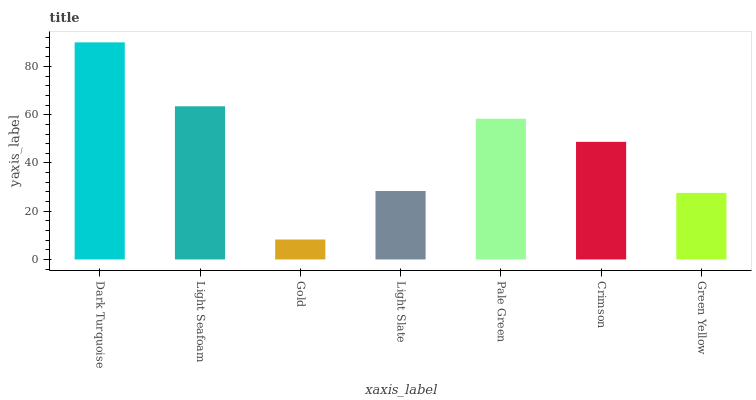Is Light Seafoam the minimum?
Answer yes or no. No. Is Light Seafoam the maximum?
Answer yes or no. No. Is Dark Turquoise greater than Light Seafoam?
Answer yes or no. Yes. Is Light Seafoam less than Dark Turquoise?
Answer yes or no. Yes. Is Light Seafoam greater than Dark Turquoise?
Answer yes or no. No. Is Dark Turquoise less than Light Seafoam?
Answer yes or no. No. Is Crimson the high median?
Answer yes or no. Yes. Is Crimson the low median?
Answer yes or no. Yes. Is Dark Turquoise the high median?
Answer yes or no. No. Is Green Yellow the low median?
Answer yes or no. No. 